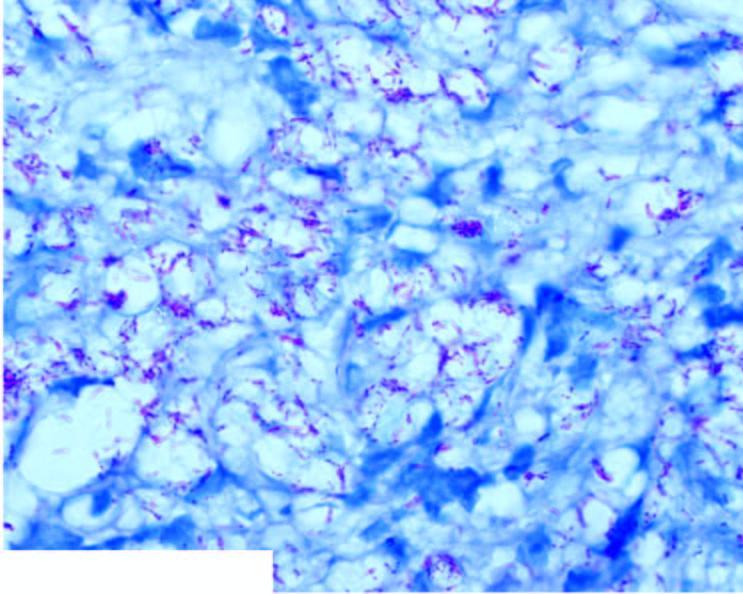do the vesselwall stain as globi and cigarettes-in-a-pack appearance inside the foam macrophages?
Answer the question using a single word or phrase. No 